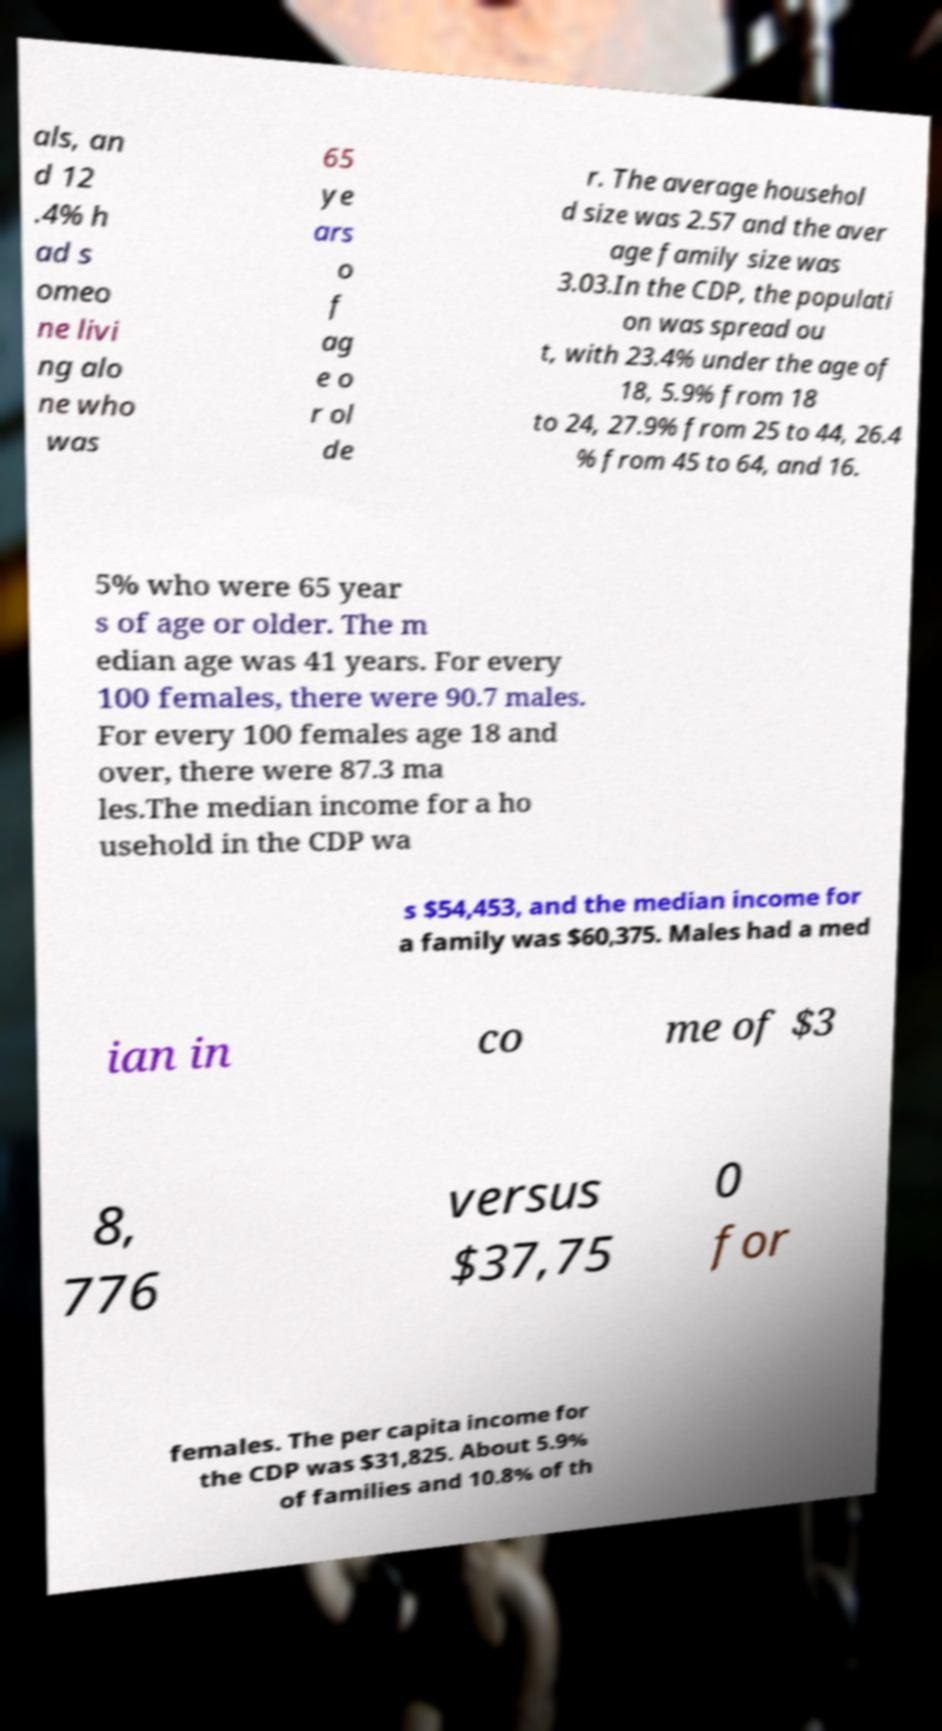Could you extract and type out the text from this image? als, an d 12 .4% h ad s omeo ne livi ng alo ne who was 65 ye ars o f ag e o r ol de r. The average househol d size was 2.57 and the aver age family size was 3.03.In the CDP, the populati on was spread ou t, with 23.4% under the age of 18, 5.9% from 18 to 24, 27.9% from 25 to 44, 26.4 % from 45 to 64, and 16. 5% who were 65 year s of age or older. The m edian age was 41 years. For every 100 females, there were 90.7 males. For every 100 females age 18 and over, there were 87.3 ma les.The median income for a ho usehold in the CDP wa s $54,453, and the median income for a family was $60,375. Males had a med ian in co me of $3 8, 776 versus $37,75 0 for females. The per capita income for the CDP was $31,825. About 5.9% of families and 10.8% of th 